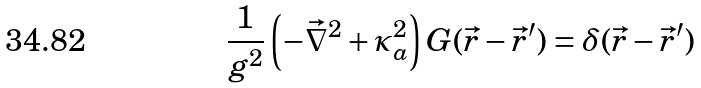<formula> <loc_0><loc_0><loc_500><loc_500>\frac { 1 } { g ^ { 2 } } \left ( - { \vec { \nabla } ^ { 2 } } + \kappa _ { a } ^ { 2 } \right ) G ( \vec { r } - \vec { r } ^ { \prime } ) = \delta ( \vec { r } - \vec { r } ^ { \prime } )</formula> 